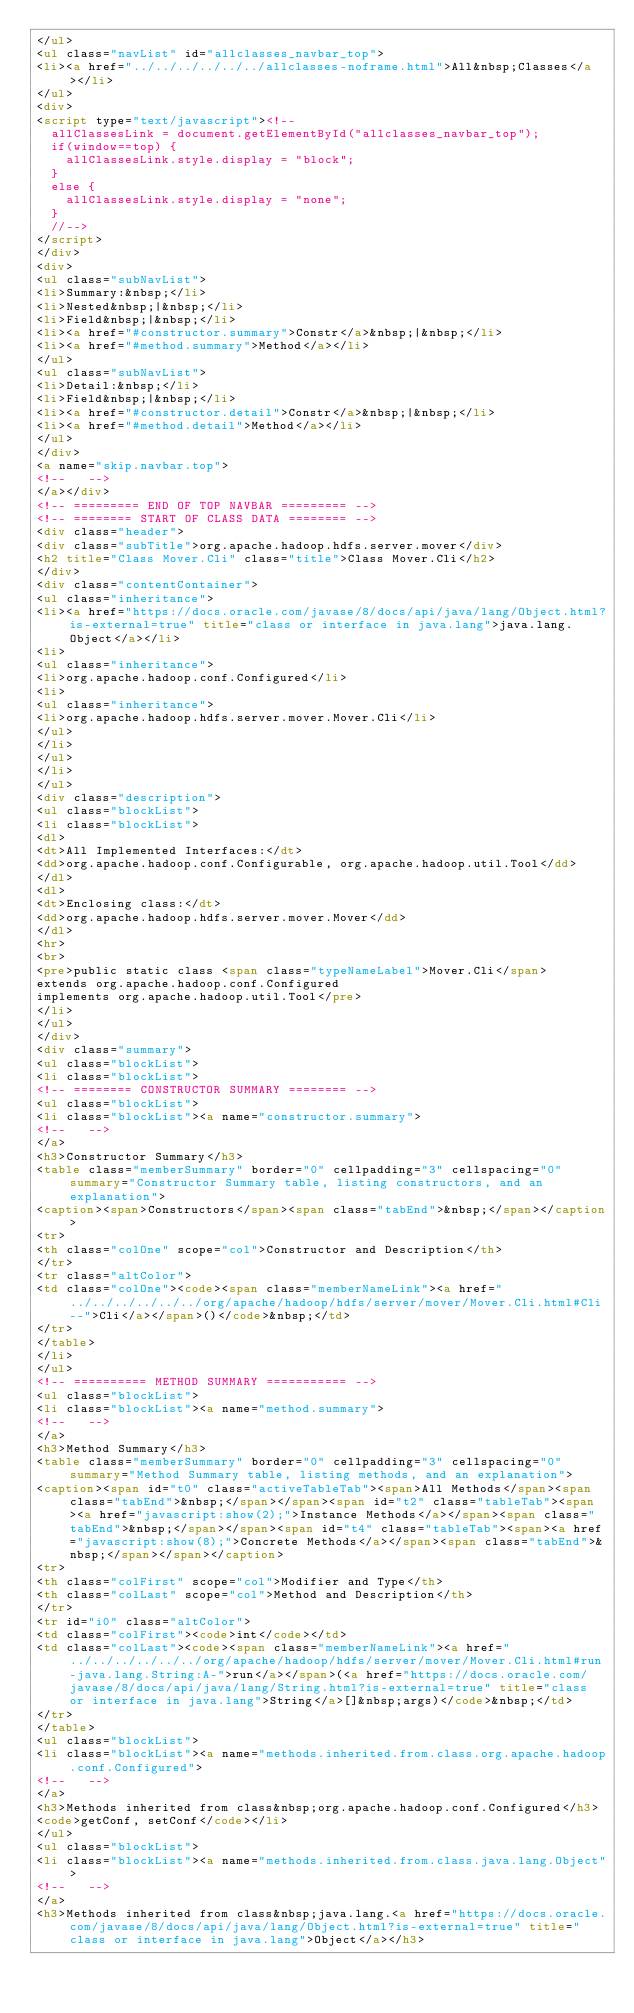Convert code to text. <code><loc_0><loc_0><loc_500><loc_500><_HTML_></ul>
<ul class="navList" id="allclasses_navbar_top">
<li><a href="../../../../../../allclasses-noframe.html">All&nbsp;Classes</a></li>
</ul>
<div>
<script type="text/javascript"><!--
  allClassesLink = document.getElementById("allclasses_navbar_top");
  if(window==top) {
    allClassesLink.style.display = "block";
  }
  else {
    allClassesLink.style.display = "none";
  }
  //-->
</script>
</div>
<div>
<ul class="subNavList">
<li>Summary:&nbsp;</li>
<li>Nested&nbsp;|&nbsp;</li>
<li>Field&nbsp;|&nbsp;</li>
<li><a href="#constructor.summary">Constr</a>&nbsp;|&nbsp;</li>
<li><a href="#method.summary">Method</a></li>
</ul>
<ul class="subNavList">
<li>Detail:&nbsp;</li>
<li>Field&nbsp;|&nbsp;</li>
<li><a href="#constructor.detail">Constr</a>&nbsp;|&nbsp;</li>
<li><a href="#method.detail">Method</a></li>
</ul>
</div>
<a name="skip.navbar.top">
<!--   -->
</a></div>
<!-- ========= END OF TOP NAVBAR ========= -->
<!-- ======== START OF CLASS DATA ======== -->
<div class="header">
<div class="subTitle">org.apache.hadoop.hdfs.server.mover</div>
<h2 title="Class Mover.Cli" class="title">Class Mover.Cli</h2>
</div>
<div class="contentContainer">
<ul class="inheritance">
<li><a href="https://docs.oracle.com/javase/8/docs/api/java/lang/Object.html?is-external=true" title="class or interface in java.lang">java.lang.Object</a></li>
<li>
<ul class="inheritance">
<li>org.apache.hadoop.conf.Configured</li>
<li>
<ul class="inheritance">
<li>org.apache.hadoop.hdfs.server.mover.Mover.Cli</li>
</ul>
</li>
</ul>
</li>
</ul>
<div class="description">
<ul class="blockList">
<li class="blockList">
<dl>
<dt>All Implemented Interfaces:</dt>
<dd>org.apache.hadoop.conf.Configurable, org.apache.hadoop.util.Tool</dd>
</dl>
<dl>
<dt>Enclosing class:</dt>
<dd>org.apache.hadoop.hdfs.server.mover.Mover</dd>
</dl>
<hr>
<br>
<pre>public static class <span class="typeNameLabel">Mover.Cli</span>
extends org.apache.hadoop.conf.Configured
implements org.apache.hadoop.util.Tool</pre>
</li>
</ul>
</div>
<div class="summary">
<ul class="blockList">
<li class="blockList">
<!-- ======== CONSTRUCTOR SUMMARY ======== -->
<ul class="blockList">
<li class="blockList"><a name="constructor.summary">
<!--   -->
</a>
<h3>Constructor Summary</h3>
<table class="memberSummary" border="0" cellpadding="3" cellspacing="0" summary="Constructor Summary table, listing constructors, and an explanation">
<caption><span>Constructors</span><span class="tabEnd">&nbsp;</span></caption>
<tr>
<th class="colOne" scope="col">Constructor and Description</th>
</tr>
<tr class="altColor">
<td class="colOne"><code><span class="memberNameLink"><a href="../../../../../../org/apache/hadoop/hdfs/server/mover/Mover.Cli.html#Cli--">Cli</a></span>()</code>&nbsp;</td>
</tr>
</table>
</li>
</ul>
<!-- ========== METHOD SUMMARY =========== -->
<ul class="blockList">
<li class="blockList"><a name="method.summary">
<!--   -->
</a>
<h3>Method Summary</h3>
<table class="memberSummary" border="0" cellpadding="3" cellspacing="0" summary="Method Summary table, listing methods, and an explanation">
<caption><span id="t0" class="activeTableTab"><span>All Methods</span><span class="tabEnd">&nbsp;</span></span><span id="t2" class="tableTab"><span><a href="javascript:show(2);">Instance Methods</a></span><span class="tabEnd">&nbsp;</span></span><span id="t4" class="tableTab"><span><a href="javascript:show(8);">Concrete Methods</a></span><span class="tabEnd">&nbsp;</span></span></caption>
<tr>
<th class="colFirst" scope="col">Modifier and Type</th>
<th class="colLast" scope="col">Method and Description</th>
</tr>
<tr id="i0" class="altColor">
<td class="colFirst"><code>int</code></td>
<td class="colLast"><code><span class="memberNameLink"><a href="../../../../../../org/apache/hadoop/hdfs/server/mover/Mover.Cli.html#run-java.lang.String:A-">run</a></span>(<a href="https://docs.oracle.com/javase/8/docs/api/java/lang/String.html?is-external=true" title="class or interface in java.lang">String</a>[]&nbsp;args)</code>&nbsp;</td>
</tr>
</table>
<ul class="blockList">
<li class="blockList"><a name="methods.inherited.from.class.org.apache.hadoop.conf.Configured">
<!--   -->
</a>
<h3>Methods inherited from class&nbsp;org.apache.hadoop.conf.Configured</h3>
<code>getConf, setConf</code></li>
</ul>
<ul class="blockList">
<li class="blockList"><a name="methods.inherited.from.class.java.lang.Object">
<!--   -->
</a>
<h3>Methods inherited from class&nbsp;java.lang.<a href="https://docs.oracle.com/javase/8/docs/api/java/lang/Object.html?is-external=true" title="class or interface in java.lang">Object</a></h3></code> 